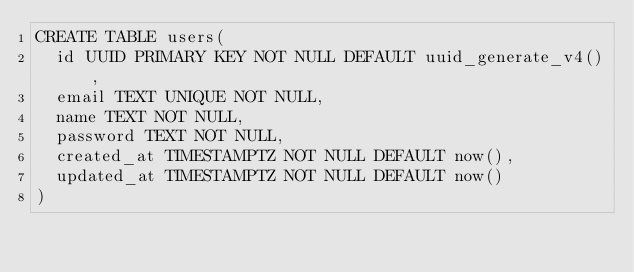<code> <loc_0><loc_0><loc_500><loc_500><_SQL_>CREATE TABLE users(
  id UUID PRIMARY KEY NOT NULL DEFAULT uuid_generate_v4(),
  email TEXT UNIQUE NOT NULL,
  name TEXT NOT NULL,
  password TEXT NOT NULL,
  created_at TIMESTAMPTZ NOT NULL DEFAULT now(),
  updated_at TIMESTAMPTZ NOT NULL DEFAULT now()
)
</code> 